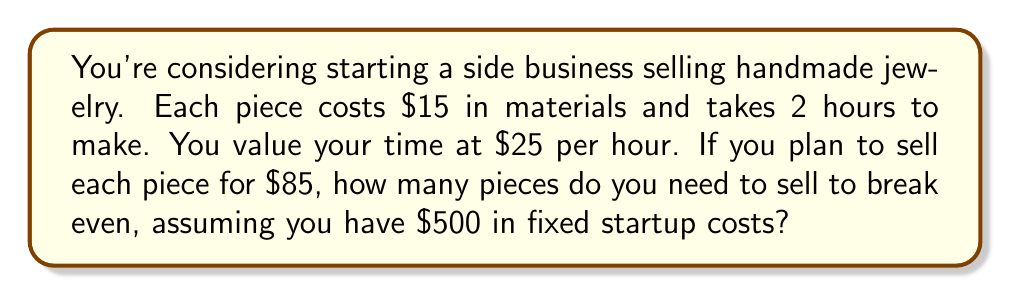Can you answer this question? Let's approach this step-by-step:

1) First, let's calculate the variable cost per piece:
   Materials: $15
   Labor: 2 hours × $25/hour = $50
   Total variable cost: $15 + $50 = $65 per piece

2) Now, let's calculate the contribution margin per piece:
   Selling price - Variable cost = $85 - $65 = $20 per piece

3) We can set up the break-even equation:
   $$ \text{Fixed Costs} + x(\text{Variable Cost}) = x(\text{Selling Price}) $$
   Where x is the number of pieces sold.

4) Plugging in our values:
   $$ 500 + 65x = 85x $$

5) Simplify:
   $$ 500 = 20x $$

6) Solve for x:
   $$ x = \frac{500}{20} = 25 $$

Therefore, you need to sell 25 pieces to break even.

To verify:
Revenue: 25 × $85 = $2,125
Total Costs: $500 + (25 × $65) = $2,125
Answer: 25 pieces 